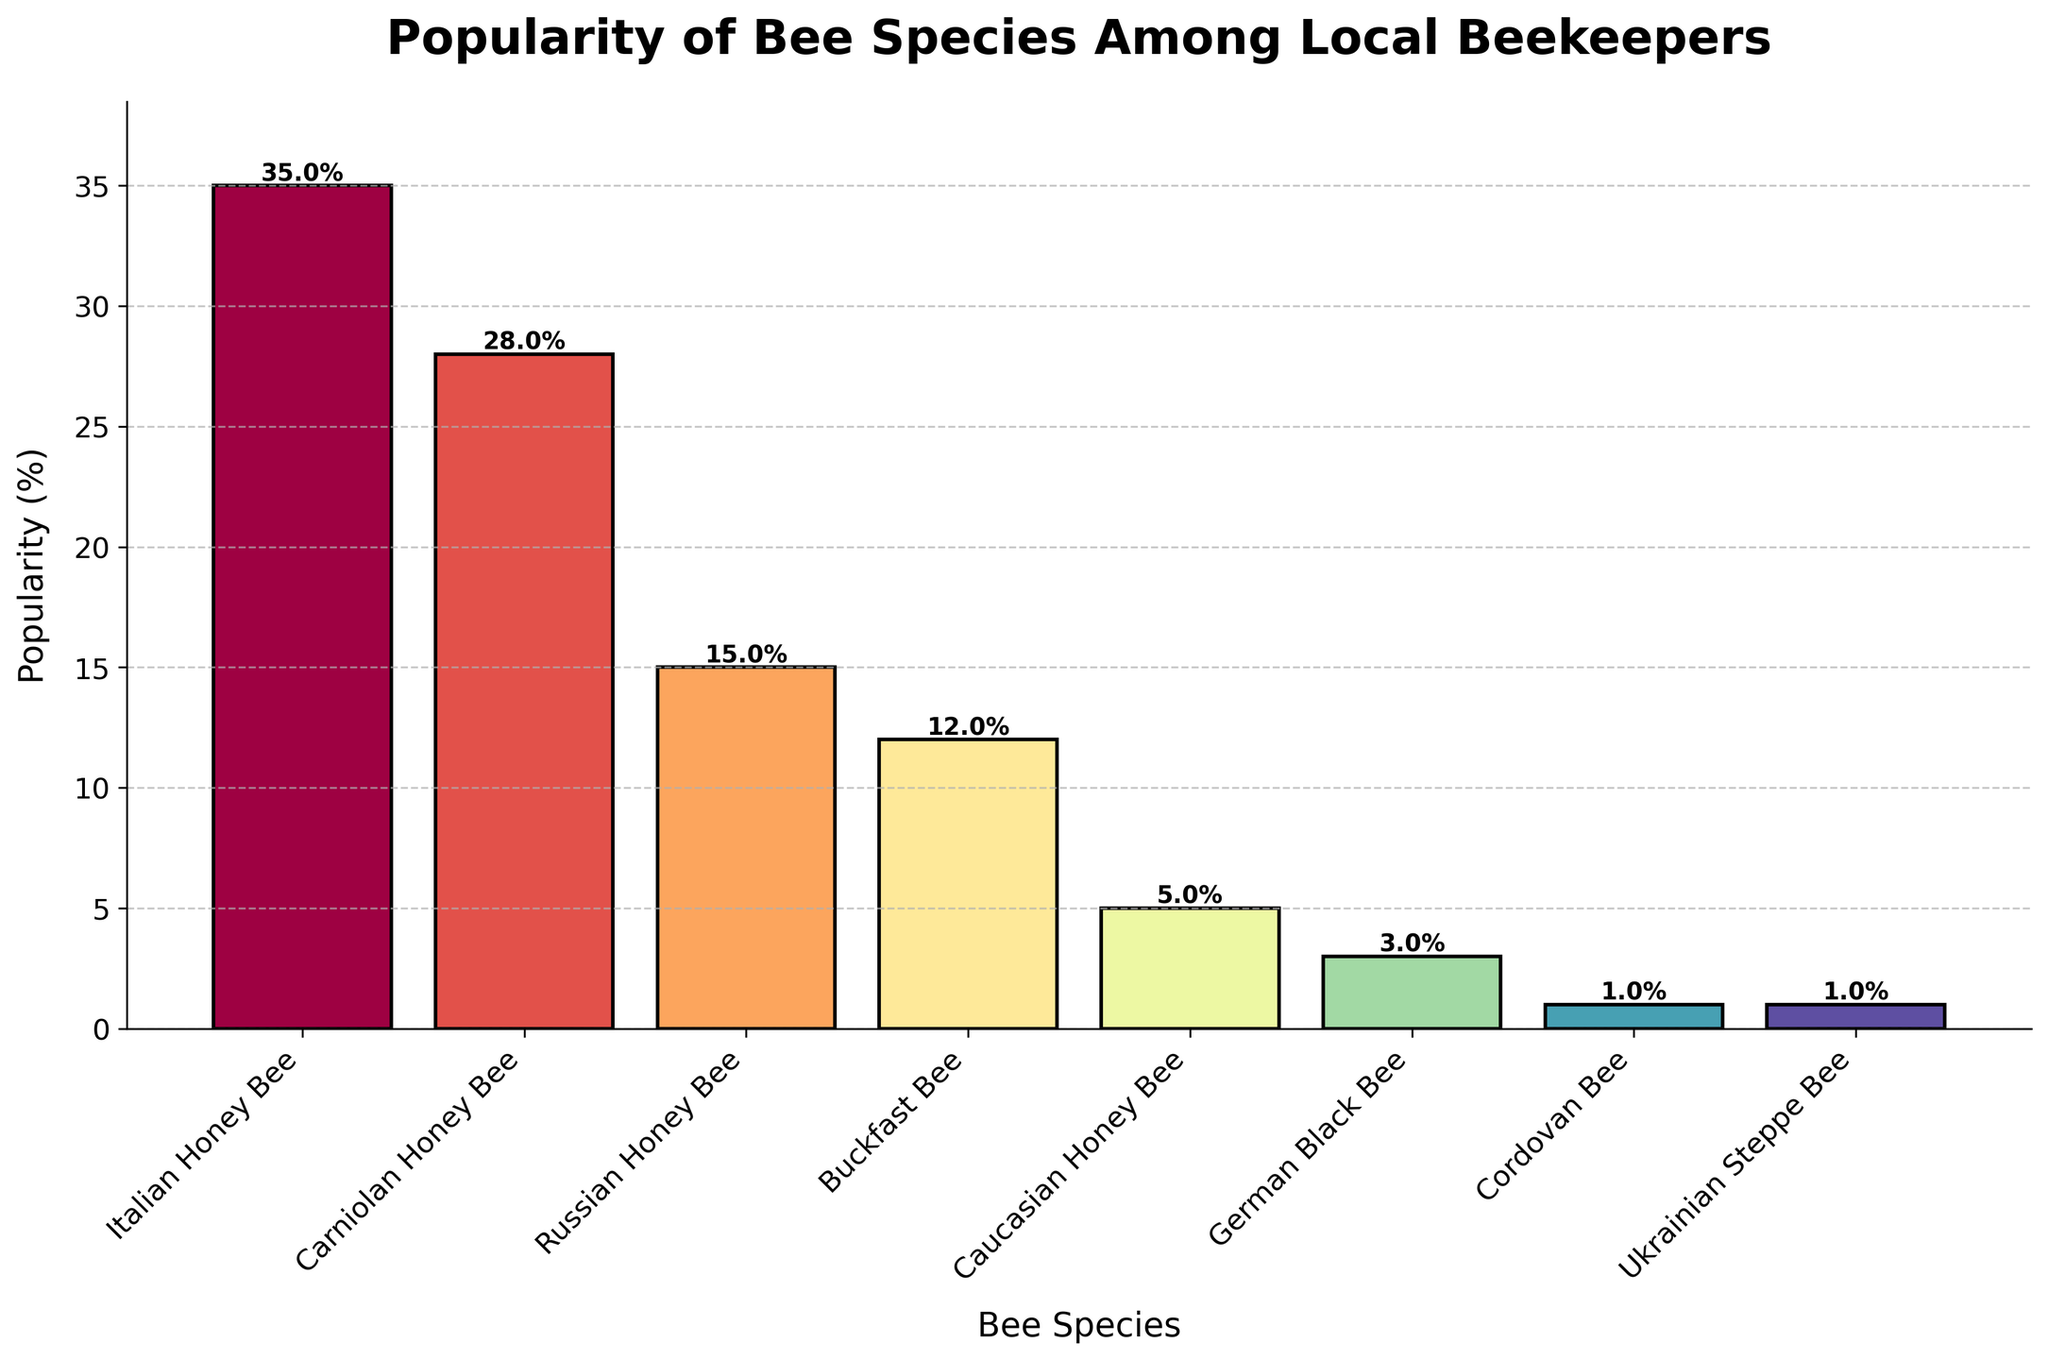Which bee species is the most popular among local beekeepers? The figure shows the percentage of popularity for each bee species. The species with the highest percentage bar is labeled as "Italian Honey Bee" with 35%.
Answer: Italian Honey Bee Which two bee species together account for more than 60% of the total popularity? By adding the popularity percentages of each species, it can be seen that "Italian Honey Bee" (35%) and "Carniolan Honey Bee" (28%) together total 63%, which is more than 60%.
Answer: Italian Honey Bee and Carniolan Honey Bee How much more popular is the Italian Honey Bee compared to the Russian Honey Bee? Subtract the percentage popularity of Russian Honey Bee (15%) from the percentage popularity of Italian Honey Bee (35%). The difference is 35% - 15% = 20%.
Answer: 20% Which bee species have a popularity percentage less than 10%? By examining the height of the bars, the species with less than 10% popularity are "Caucasian Honey Bee" (5%), "German Black Bee" (3%), "Cordovan Bee" (1%), and "Ukrainian Steppe Bee" (1%).
Answer: Caucasian Honey Bee, German Black Bee, Cordovan Bee, Ukrainian Steppe Bee What is the combined popularity of Buckfast Bee and Caucasian Honey Bee? Add the popularity percentages of Buckfast Bee (12%) and Caucasian Honey Bee (5%). The total is 12% + 5% = 17%.
Answer: 17% Which has a higher popularity, Carniolan Honey Bee or Buckfast Bee? And by how much? Compare the percentages of Carniolan Honey Bee (28%) and Buckfast Bee (12%). Carniolan Honey Bee is more popular by subtracting Buckfast Bee's percentage: 28% - 12% = 16%.
Answer: Carniolan Honey Bee by 16% Out of the bee species listed, how many have a popularity of at least 15%? Identifying from the bars' heights, the species with at least 15% popularity are "Italian Honey Bee" (35%), "Carniolan Honey Bee" (28%), and "Russian Honey Bee" (15%). Count is 3.
Answer: 3 If you were to combine the popularity of the least popular species, German Black Bee, Cordovan Bee, and Ukrainian Steppe Bee, what would their total share reach? Add the percentages of German Black Bee (3%), Cordovan Bee (1%), and Ukrainian Steppe Bee (1%). The total is 3% + 1% + 1% = 5%.
Answer: 5% 